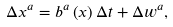<formula> <loc_0><loc_0><loc_500><loc_500>\Delta x ^ { a } = b ^ { a } \left ( x \right ) \Delta t + \Delta w ^ { a } ,</formula> 